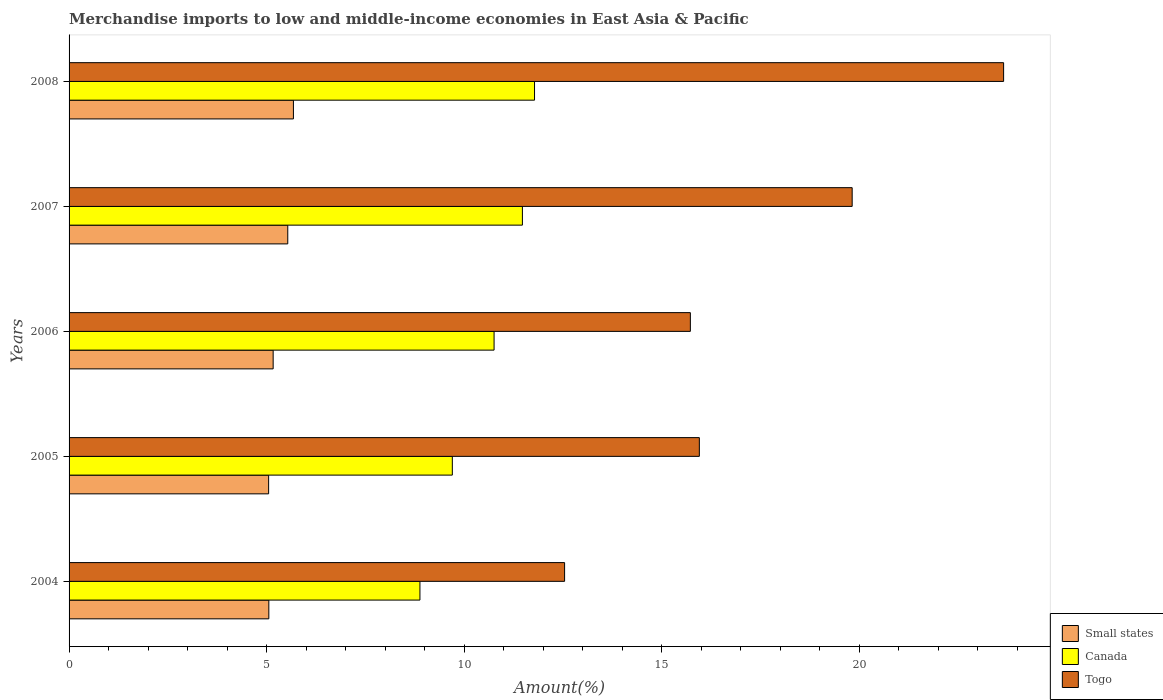How many groups of bars are there?
Your answer should be compact. 5. Are the number of bars on each tick of the Y-axis equal?
Provide a short and direct response. Yes. How many bars are there on the 5th tick from the top?
Offer a very short reply. 3. In how many cases, is the number of bars for a given year not equal to the number of legend labels?
Give a very brief answer. 0. What is the percentage of amount earned from merchandise imports in Small states in 2007?
Your response must be concise. 5.53. Across all years, what is the maximum percentage of amount earned from merchandise imports in Togo?
Your answer should be very brief. 23.65. Across all years, what is the minimum percentage of amount earned from merchandise imports in Canada?
Your answer should be compact. 8.88. What is the total percentage of amount earned from merchandise imports in Togo in the graph?
Offer a terse response. 87.68. What is the difference between the percentage of amount earned from merchandise imports in Canada in 2004 and that in 2005?
Provide a succinct answer. -0.82. What is the difference between the percentage of amount earned from merchandise imports in Canada in 2006 and the percentage of amount earned from merchandise imports in Small states in 2005?
Offer a terse response. 5.71. What is the average percentage of amount earned from merchandise imports in Canada per year?
Give a very brief answer. 10.52. In the year 2008, what is the difference between the percentage of amount earned from merchandise imports in Canada and percentage of amount earned from merchandise imports in Small states?
Make the answer very short. 6.1. In how many years, is the percentage of amount earned from merchandise imports in Togo greater than 14 %?
Ensure brevity in your answer.  4. What is the ratio of the percentage of amount earned from merchandise imports in Small states in 2005 to that in 2006?
Ensure brevity in your answer.  0.98. Is the percentage of amount earned from merchandise imports in Small states in 2007 less than that in 2008?
Offer a very short reply. Yes. Is the difference between the percentage of amount earned from merchandise imports in Canada in 2007 and 2008 greater than the difference between the percentage of amount earned from merchandise imports in Small states in 2007 and 2008?
Keep it short and to the point. No. What is the difference between the highest and the second highest percentage of amount earned from merchandise imports in Togo?
Keep it short and to the point. 3.83. What is the difference between the highest and the lowest percentage of amount earned from merchandise imports in Togo?
Give a very brief answer. 11.11. What does the 3rd bar from the top in 2006 represents?
Give a very brief answer. Small states. What does the 1st bar from the bottom in 2008 represents?
Provide a succinct answer. Small states. Is it the case that in every year, the sum of the percentage of amount earned from merchandise imports in Togo and percentage of amount earned from merchandise imports in Small states is greater than the percentage of amount earned from merchandise imports in Canada?
Give a very brief answer. Yes. How many bars are there?
Offer a terse response. 15. Are all the bars in the graph horizontal?
Your answer should be compact. Yes. Does the graph contain any zero values?
Provide a succinct answer. No. Where does the legend appear in the graph?
Make the answer very short. Bottom right. How many legend labels are there?
Ensure brevity in your answer.  3. What is the title of the graph?
Keep it short and to the point. Merchandise imports to low and middle-income economies in East Asia & Pacific. Does "India" appear as one of the legend labels in the graph?
Make the answer very short. No. What is the label or title of the X-axis?
Offer a very short reply. Amount(%). What is the label or title of the Y-axis?
Make the answer very short. Years. What is the Amount(%) in Small states in 2004?
Keep it short and to the point. 5.06. What is the Amount(%) of Canada in 2004?
Provide a short and direct response. 8.88. What is the Amount(%) of Togo in 2004?
Provide a short and direct response. 12.54. What is the Amount(%) of Small states in 2005?
Make the answer very short. 5.05. What is the Amount(%) in Canada in 2005?
Give a very brief answer. 9.7. What is the Amount(%) in Togo in 2005?
Keep it short and to the point. 15.95. What is the Amount(%) in Small states in 2006?
Offer a terse response. 5.16. What is the Amount(%) in Canada in 2006?
Your response must be concise. 10.76. What is the Amount(%) of Togo in 2006?
Offer a very short reply. 15.72. What is the Amount(%) in Small states in 2007?
Offer a very short reply. 5.53. What is the Amount(%) in Canada in 2007?
Your response must be concise. 11.47. What is the Amount(%) in Togo in 2007?
Provide a succinct answer. 19.82. What is the Amount(%) of Small states in 2008?
Give a very brief answer. 5.68. What is the Amount(%) of Canada in 2008?
Your answer should be compact. 11.78. What is the Amount(%) in Togo in 2008?
Your response must be concise. 23.65. Across all years, what is the maximum Amount(%) of Small states?
Your answer should be very brief. 5.68. Across all years, what is the maximum Amount(%) of Canada?
Make the answer very short. 11.78. Across all years, what is the maximum Amount(%) of Togo?
Your response must be concise. 23.65. Across all years, what is the minimum Amount(%) of Small states?
Ensure brevity in your answer.  5.05. Across all years, what is the minimum Amount(%) in Canada?
Offer a very short reply. 8.88. Across all years, what is the minimum Amount(%) in Togo?
Provide a short and direct response. 12.54. What is the total Amount(%) of Small states in the graph?
Offer a terse response. 26.48. What is the total Amount(%) in Canada in the graph?
Keep it short and to the point. 52.58. What is the total Amount(%) of Togo in the graph?
Your response must be concise. 87.68. What is the difference between the Amount(%) in Small states in 2004 and that in 2005?
Offer a very short reply. 0.01. What is the difference between the Amount(%) of Canada in 2004 and that in 2005?
Keep it short and to the point. -0.82. What is the difference between the Amount(%) in Togo in 2004 and that in 2005?
Offer a terse response. -3.41. What is the difference between the Amount(%) of Small states in 2004 and that in 2006?
Your response must be concise. -0.11. What is the difference between the Amount(%) of Canada in 2004 and that in 2006?
Provide a succinct answer. -1.88. What is the difference between the Amount(%) of Togo in 2004 and that in 2006?
Your response must be concise. -3.18. What is the difference between the Amount(%) in Small states in 2004 and that in 2007?
Your answer should be very brief. -0.48. What is the difference between the Amount(%) in Canada in 2004 and that in 2007?
Your response must be concise. -2.59. What is the difference between the Amount(%) in Togo in 2004 and that in 2007?
Your answer should be very brief. -7.28. What is the difference between the Amount(%) in Small states in 2004 and that in 2008?
Ensure brevity in your answer.  -0.62. What is the difference between the Amount(%) in Canada in 2004 and that in 2008?
Ensure brevity in your answer.  -2.9. What is the difference between the Amount(%) in Togo in 2004 and that in 2008?
Keep it short and to the point. -11.11. What is the difference between the Amount(%) of Small states in 2005 and that in 2006?
Give a very brief answer. -0.11. What is the difference between the Amount(%) of Canada in 2005 and that in 2006?
Your response must be concise. -1.06. What is the difference between the Amount(%) in Togo in 2005 and that in 2006?
Your answer should be very brief. 0.23. What is the difference between the Amount(%) in Small states in 2005 and that in 2007?
Your answer should be compact. -0.48. What is the difference between the Amount(%) in Canada in 2005 and that in 2007?
Offer a terse response. -1.77. What is the difference between the Amount(%) of Togo in 2005 and that in 2007?
Offer a terse response. -3.87. What is the difference between the Amount(%) in Small states in 2005 and that in 2008?
Give a very brief answer. -0.63. What is the difference between the Amount(%) of Canada in 2005 and that in 2008?
Provide a succinct answer. -2.08. What is the difference between the Amount(%) in Togo in 2005 and that in 2008?
Make the answer very short. -7.7. What is the difference between the Amount(%) in Small states in 2006 and that in 2007?
Your response must be concise. -0.37. What is the difference between the Amount(%) of Canada in 2006 and that in 2007?
Offer a terse response. -0.72. What is the difference between the Amount(%) of Togo in 2006 and that in 2007?
Your response must be concise. -4.09. What is the difference between the Amount(%) in Small states in 2006 and that in 2008?
Make the answer very short. -0.51. What is the difference between the Amount(%) in Canada in 2006 and that in 2008?
Your answer should be compact. -1.02. What is the difference between the Amount(%) in Togo in 2006 and that in 2008?
Your response must be concise. -7.93. What is the difference between the Amount(%) of Small states in 2007 and that in 2008?
Keep it short and to the point. -0.14. What is the difference between the Amount(%) of Canada in 2007 and that in 2008?
Provide a succinct answer. -0.31. What is the difference between the Amount(%) of Togo in 2007 and that in 2008?
Your answer should be very brief. -3.83. What is the difference between the Amount(%) in Small states in 2004 and the Amount(%) in Canada in 2005?
Keep it short and to the point. -4.64. What is the difference between the Amount(%) of Small states in 2004 and the Amount(%) of Togo in 2005?
Your response must be concise. -10.89. What is the difference between the Amount(%) of Canada in 2004 and the Amount(%) of Togo in 2005?
Your answer should be very brief. -7.07. What is the difference between the Amount(%) in Small states in 2004 and the Amount(%) in Canada in 2006?
Ensure brevity in your answer.  -5.7. What is the difference between the Amount(%) in Small states in 2004 and the Amount(%) in Togo in 2006?
Keep it short and to the point. -10.67. What is the difference between the Amount(%) in Canada in 2004 and the Amount(%) in Togo in 2006?
Offer a very short reply. -6.84. What is the difference between the Amount(%) in Small states in 2004 and the Amount(%) in Canada in 2007?
Provide a succinct answer. -6.42. What is the difference between the Amount(%) in Small states in 2004 and the Amount(%) in Togo in 2007?
Your answer should be very brief. -14.76. What is the difference between the Amount(%) in Canada in 2004 and the Amount(%) in Togo in 2007?
Provide a succinct answer. -10.94. What is the difference between the Amount(%) in Small states in 2004 and the Amount(%) in Canada in 2008?
Your answer should be very brief. -6.72. What is the difference between the Amount(%) in Small states in 2004 and the Amount(%) in Togo in 2008?
Make the answer very short. -18.59. What is the difference between the Amount(%) of Canada in 2004 and the Amount(%) of Togo in 2008?
Ensure brevity in your answer.  -14.77. What is the difference between the Amount(%) in Small states in 2005 and the Amount(%) in Canada in 2006?
Your answer should be compact. -5.71. What is the difference between the Amount(%) in Small states in 2005 and the Amount(%) in Togo in 2006?
Make the answer very short. -10.67. What is the difference between the Amount(%) of Canada in 2005 and the Amount(%) of Togo in 2006?
Offer a very short reply. -6.02. What is the difference between the Amount(%) in Small states in 2005 and the Amount(%) in Canada in 2007?
Your answer should be very brief. -6.42. What is the difference between the Amount(%) in Small states in 2005 and the Amount(%) in Togo in 2007?
Ensure brevity in your answer.  -14.77. What is the difference between the Amount(%) of Canada in 2005 and the Amount(%) of Togo in 2007?
Ensure brevity in your answer.  -10.12. What is the difference between the Amount(%) in Small states in 2005 and the Amount(%) in Canada in 2008?
Keep it short and to the point. -6.73. What is the difference between the Amount(%) of Small states in 2005 and the Amount(%) of Togo in 2008?
Offer a very short reply. -18.6. What is the difference between the Amount(%) of Canada in 2005 and the Amount(%) of Togo in 2008?
Your answer should be very brief. -13.95. What is the difference between the Amount(%) in Small states in 2006 and the Amount(%) in Canada in 2007?
Keep it short and to the point. -6.31. What is the difference between the Amount(%) in Small states in 2006 and the Amount(%) in Togo in 2007?
Your response must be concise. -14.65. What is the difference between the Amount(%) in Canada in 2006 and the Amount(%) in Togo in 2007?
Your response must be concise. -9.06. What is the difference between the Amount(%) in Small states in 2006 and the Amount(%) in Canada in 2008?
Your response must be concise. -6.61. What is the difference between the Amount(%) in Small states in 2006 and the Amount(%) in Togo in 2008?
Offer a very short reply. -18.48. What is the difference between the Amount(%) of Canada in 2006 and the Amount(%) of Togo in 2008?
Give a very brief answer. -12.89. What is the difference between the Amount(%) of Small states in 2007 and the Amount(%) of Canada in 2008?
Provide a succinct answer. -6.24. What is the difference between the Amount(%) of Small states in 2007 and the Amount(%) of Togo in 2008?
Keep it short and to the point. -18.11. What is the difference between the Amount(%) in Canada in 2007 and the Amount(%) in Togo in 2008?
Your answer should be compact. -12.18. What is the average Amount(%) in Small states per year?
Offer a terse response. 5.3. What is the average Amount(%) of Canada per year?
Your response must be concise. 10.52. What is the average Amount(%) in Togo per year?
Provide a succinct answer. 17.54. In the year 2004, what is the difference between the Amount(%) of Small states and Amount(%) of Canada?
Offer a very short reply. -3.82. In the year 2004, what is the difference between the Amount(%) of Small states and Amount(%) of Togo?
Offer a terse response. -7.48. In the year 2004, what is the difference between the Amount(%) of Canada and Amount(%) of Togo?
Your answer should be compact. -3.66. In the year 2005, what is the difference between the Amount(%) of Small states and Amount(%) of Canada?
Ensure brevity in your answer.  -4.65. In the year 2005, what is the difference between the Amount(%) in Small states and Amount(%) in Togo?
Offer a very short reply. -10.9. In the year 2005, what is the difference between the Amount(%) of Canada and Amount(%) of Togo?
Give a very brief answer. -6.25. In the year 2006, what is the difference between the Amount(%) of Small states and Amount(%) of Canada?
Offer a very short reply. -5.59. In the year 2006, what is the difference between the Amount(%) of Small states and Amount(%) of Togo?
Make the answer very short. -10.56. In the year 2006, what is the difference between the Amount(%) in Canada and Amount(%) in Togo?
Give a very brief answer. -4.97. In the year 2007, what is the difference between the Amount(%) in Small states and Amount(%) in Canada?
Provide a succinct answer. -5.94. In the year 2007, what is the difference between the Amount(%) of Small states and Amount(%) of Togo?
Make the answer very short. -14.28. In the year 2007, what is the difference between the Amount(%) in Canada and Amount(%) in Togo?
Offer a terse response. -8.35. In the year 2008, what is the difference between the Amount(%) in Small states and Amount(%) in Canada?
Provide a short and direct response. -6.1. In the year 2008, what is the difference between the Amount(%) in Small states and Amount(%) in Togo?
Offer a terse response. -17.97. In the year 2008, what is the difference between the Amount(%) of Canada and Amount(%) of Togo?
Your answer should be very brief. -11.87. What is the ratio of the Amount(%) in Canada in 2004 to that in 2005?
Give a very brief answer. 0.92. What is the ratio of the Amount(%) of Togo in 2004 to that in 2005?
Provide a succinct answer. 0.79. What is the ratio of the Amount(%) of Small states in 2004 to that in 2006?
Ensure brevity in your answer.  0.98. What is the ratio of the Amount(%) of Canada in 2004 to that in 2006?
Your answer should be very brief. 0.83. What is the ratio of the Amount(%) in Togo in 2004 to that in 2006?
Your answer should be very brief. 0.8. What is the ratio of the Amount(%) of Small states in 2004 to that in 2007?
Provide a short and direct response. 0.91. What is the ratio of the Amount(%) of Canada in 2004 to that in 2007?
Keep it short and to the point. 0.77. What is the ratio of the Amount(%) of Togo in 2004 to that in 2007?
Your answer should be very brief. 0.63. What is the ratio of the Amount(%) of Small states in 2004 to that in 2008?
Give a very brief answer. 0.89. What is the ratio of the Amount(%) in Canada in 2004 to that in 2008?
Make the answer very short. 0.75. What is the ratio of the Amount(%) in Togo in 2004 to that in 2008?
Give a very brief answer. 0.53. What is the ratio of the Amount(%) in Small states in 2005 to that in 2006?
Make the answer very short. 0.98. What is the ratio of the Amount(%) of Canada in 2005 to that in 2006?
Offer a very short reply. 0.9. What is the ratio of the Amount(%) of Togo in 2005 to that in 2006?
Your answer should be compact. 1.01. What is the ratio of the Amount(%) of Small states in 2005 to that in 2007?
Keep it short and to the point. 0.91. What is the ratio of the Amount(%) of Canada in 2005 to that in 2007?
Keep it short and to the point. 0.85. What is the ratio of the Amount(%) of Togo in 2005 to that in 2007?
Provide a succinct answer. 0.8. What is the ratio of the Amount(%) in Small states in 2005 to that in 2008?
Provide a succinct answer. 0.89. What is the ratio of the Amount(%) in Canada in 2005 to that in 2008?
Offer a terse response. 0.82. What is the ratio of the Amount(%) of Togo in 2005 to that in 2008?
Your answer should be very brief. 0.67. What is the ratio of the Amount(%) in Small states in 2006 to that in 2007?
Make the answer very short. 0.93. What is the ratio of the Amount(%) of Canada in 2006 to that in 2007?
Ensure brevity in your answer.  0.94. What is the ratio of the Amount(%) in Togo in 2006 to that in 2007?
Provide a short and direct response. 0.79. What is the ratio of the Amount(%) in Small states in 2006 to that in 2008?
Provide a short and direct response. 0.91. What is the ratio of the Amount(%) in Canada in 2006 to that in 2008?
Provide a succinct answer. 0.91. What is the ratio of the Amount(%) of Togo in 2006 to that in 2008?
Offer a terse response. 0.66. What is the ratio of the Amount(%) in Small states in 2007 to that in 2008?
Make the answer very short. 0.97. What is the ratio of the Amount(%) of Canada in 2007 to that in 2008?
Offer a very short reply. 0.97. What is the ratio of the Amount(%) in Togo in 2007 to that in 2008?
Ensure brevity in your answer.  0.84. What is the difference between the highest and the second highest Amount(%) in Small states?
Ensure brevity in your answer.  0.14. What is the difference between the highest and the second highest Amount(%) in Canada?
Provide a short and direct response. 0.31. What is the difference between the highest and the second highest Amount(%) in Togo?
Provide a short and direct response. 3.83. What is the difference between the highest and the lowest Amount(%) in Small states?
Ensure brevity in your answer.  0.63. What is the difference between the highest and the lowest Amount(%) in Canada?
Your answer should be very brief. 2.9. What is the difference between the highest and the lowest Amount(%) of Togo?
Your answer should be very brief. 11.11. 